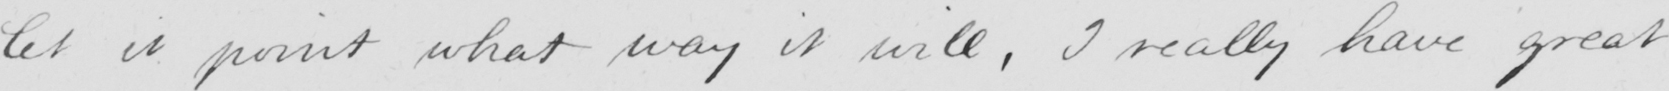Transcribe the text shown in this historical manuscript line. let it point what way it will , I really have great 